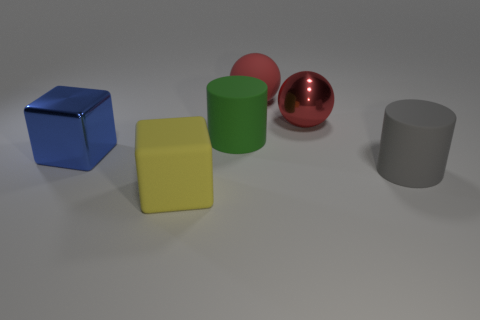Add 1 tiny red metallic spheres. How many objects exist? 7 Subtract all spheres. How many objects are left? 4 Add 4 big red matte spheres. How many big red matte spheres exist? 5 Subtract 2 red spheres. How many objects are left? 4 Subtract all small red shiny cubes. Subtract all big green cylinders. How many objects are left? 5 Add 3 shiny objects. How many shiny objects are left? 5 